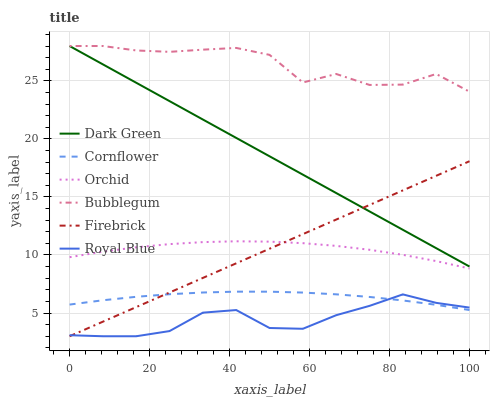Does Royal Blue have the minimum area under the curve?
Answer yes or no. Yes. Does Bubblegum have the maximum area under the curve?
Answer yes or no. Yes. Does Firebrick have the minimum area under the curve?
Answer yes or no. No. Does Firebrick have the maximum area under the curve?
Answer yes or no. No. Is Firebrick the smoothest?
Answer yes or no. Yes. Is Bubblegum the roughest?
Answer yes or no. Yes. Is Bubblegum the smoothest?
Answer yes or no. No. Is Firebrick the roughest?
Answer yes or no. No. Does Firebrick have the lowest value?
Answer yes or no. Yes. Does Bubblegum have the lowest value?
Answer yes or no. No. Does Dark Green have the highest value?
Answer yes or no. Yes. Does Firebrick have the highest value?
Answer yes or no. No. Is Royal Blue less than Bubblegum?
Answer yes or no. Yes. Is Dark Green greater than Royal Blue?
Answer yes or no. Yes. Does Firebrick intersect Cornflower?
Answer yes or no. Yes. Is Firebrick less than Cornflower?
Answer yes or no. No. Is Firebrick greater than Cornflower?
Answer yes or no. No. Does Royal Blue intersect Bubblegum?
Answer yes or no. No. 